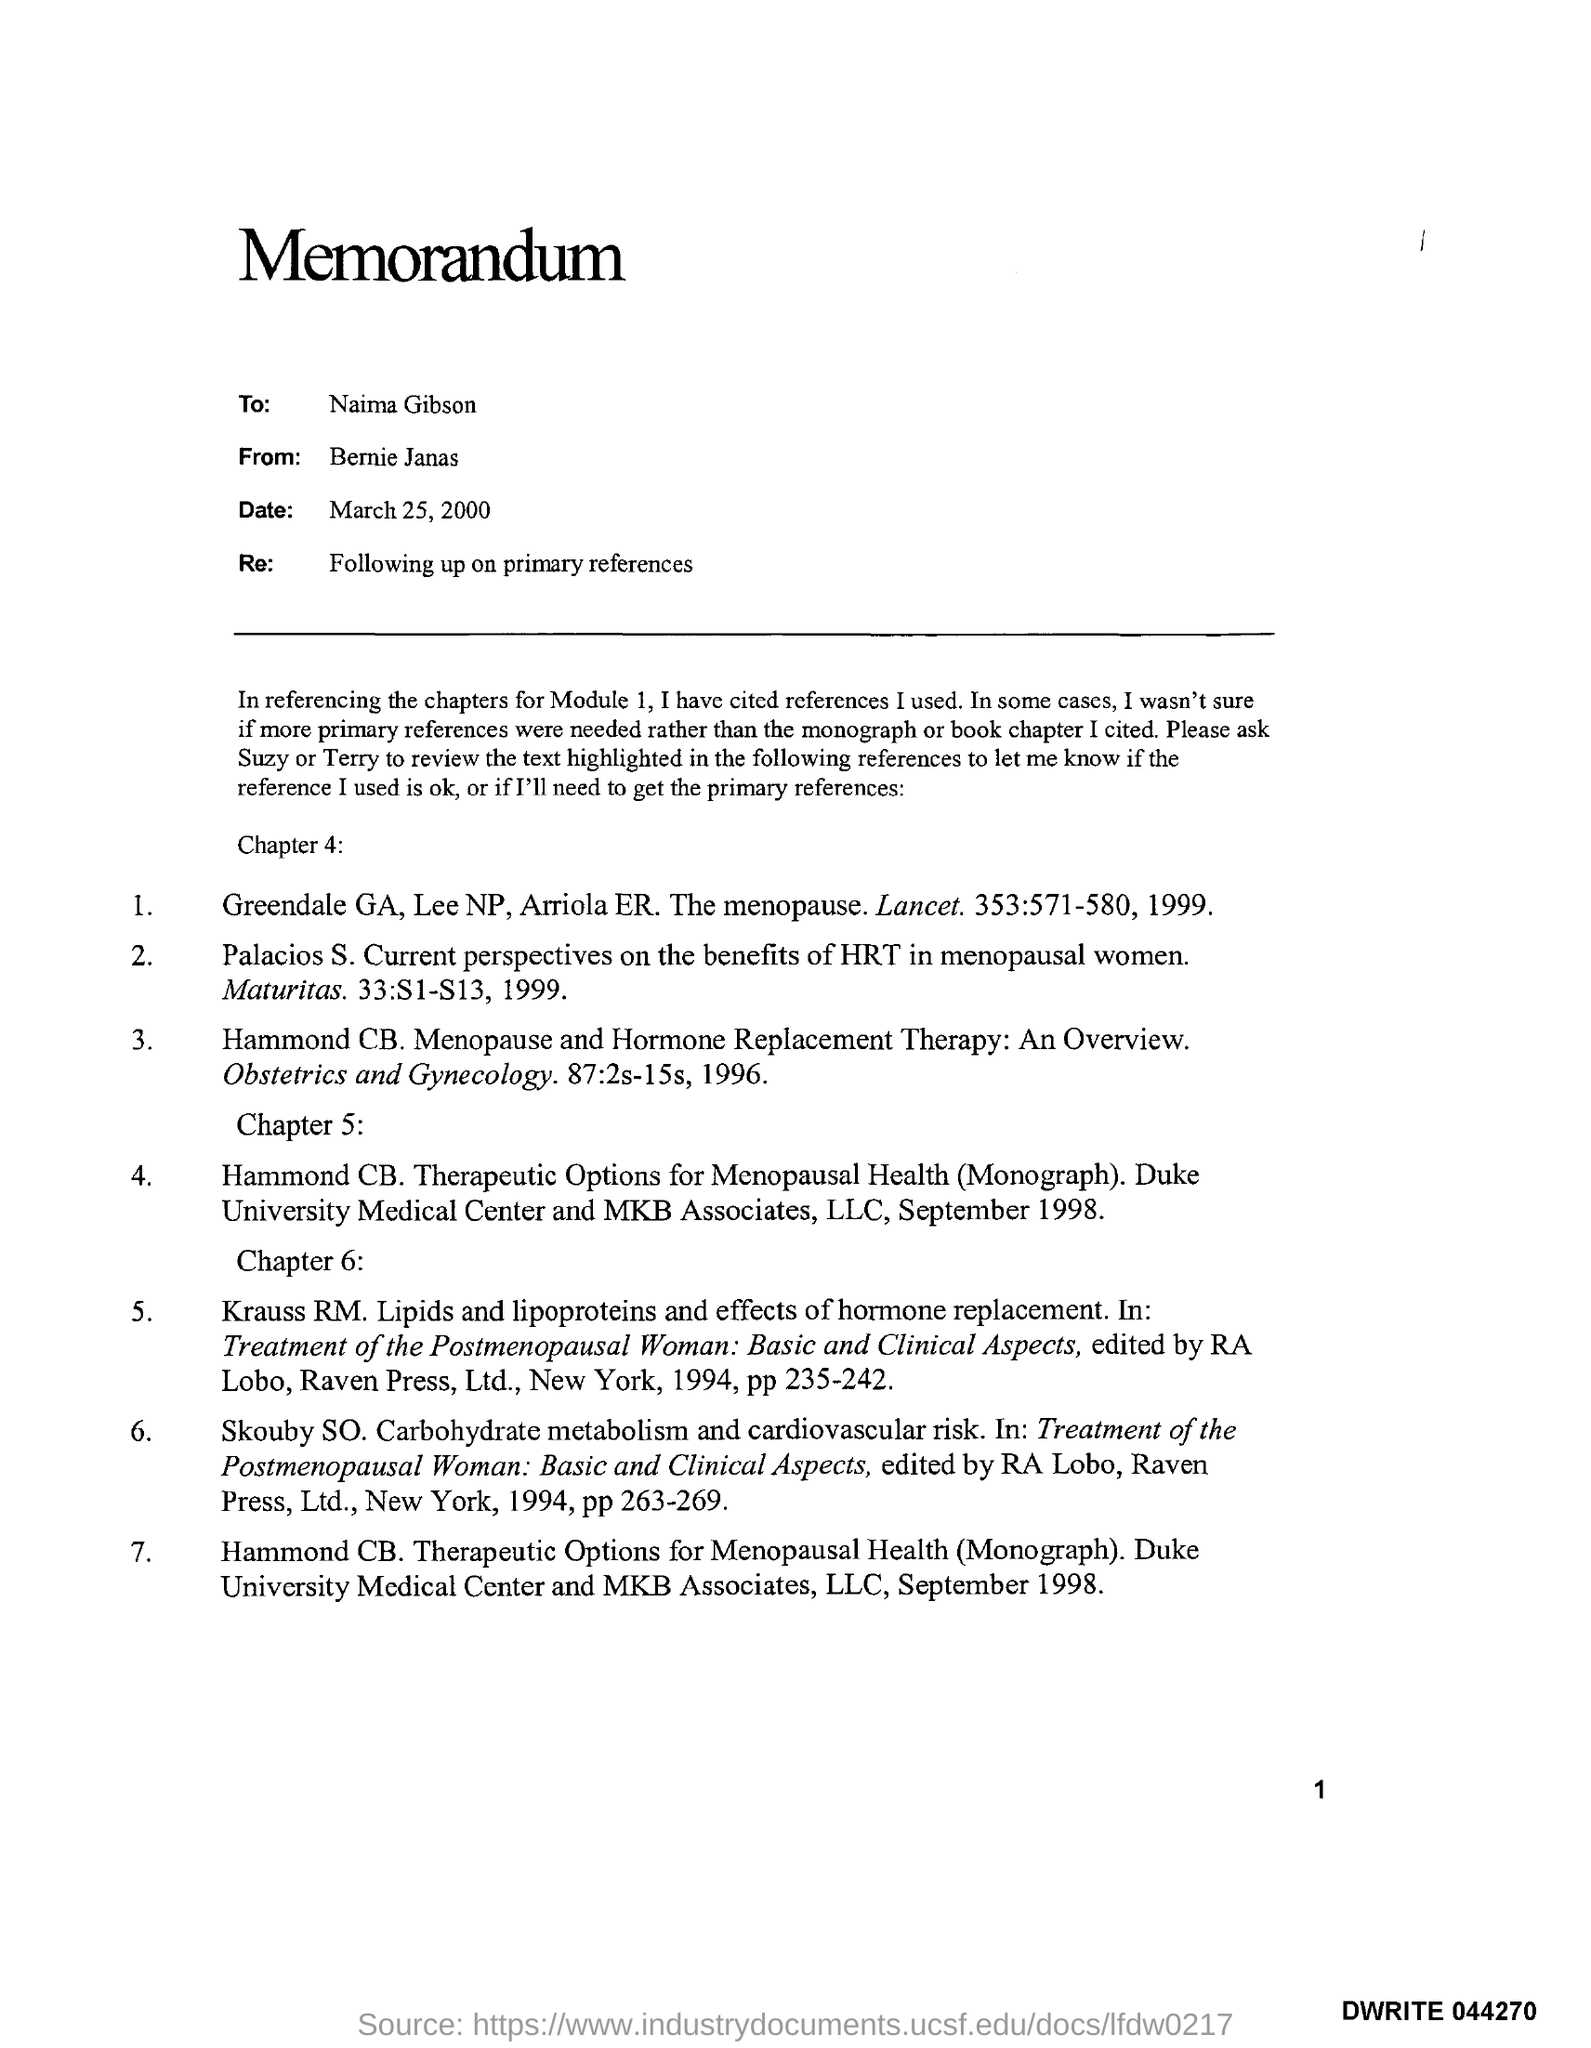Who is the Memorandum addressed to ?
Offer a terse response. Naima Gibson. Who is the Memorandum from ?
Your answer should be very brief. Bernie Janas. What is the date mentioned in the top of the document ?
Ensure brevity in your answer.  March 25, 2000. What is written in the "Re" field ?
Provide a short and direct response. Following up on primary references. What is written in the Letter Head ?
Give a very brief answer. Memorandum. 